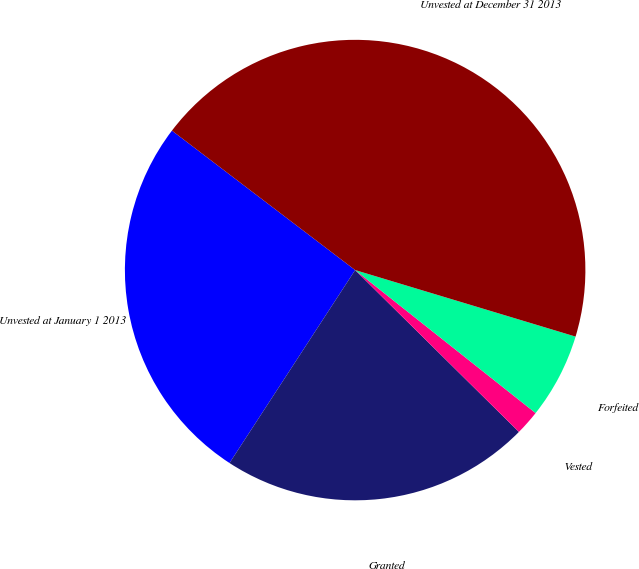Convert chart to OTSL. <chart><loc_0><loc_0><loc_500><loc_500><pie_chart><fcel>Unvested at January 1 2013<fcel>Granted<fcel>Vested<fcel>Forfeited<fcel>Unvested at December 31 2013<nl><fcel>26.17%<fcel>21.78%<fcel>1.74%<fcel>6.0%<fcel>44.31%<nl></chart> 